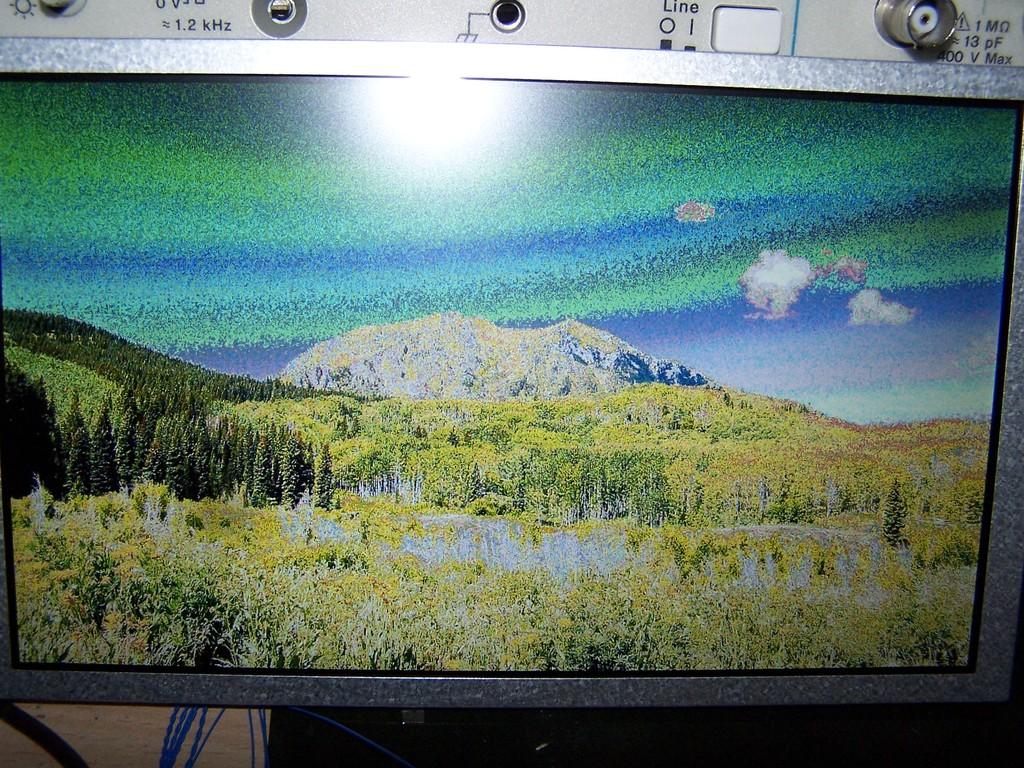How many khz?
Make the answer very short. 1.2. 